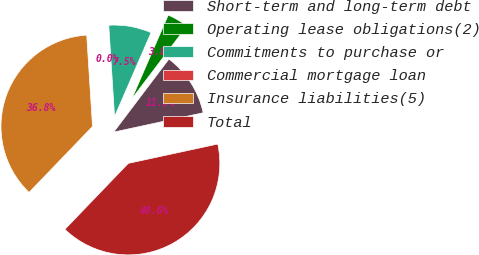Convert chart. <chart><loc_0><loc_0><loc_500><loc_500><pie_chart><fcel>Short-term and long-term debt<fcel>Operating lease obligations(2)<fcel>Commitments to purchase or<fcel>Commercial mortgage loan<fcel>Insurance liabilities(5)<fcel>Total<nl><fcel>11.31%<fcel>3.77%<fcel>7.54%<fcel>0.0%<fcel>36.8%<fcel>40.57%<nl></chart> 